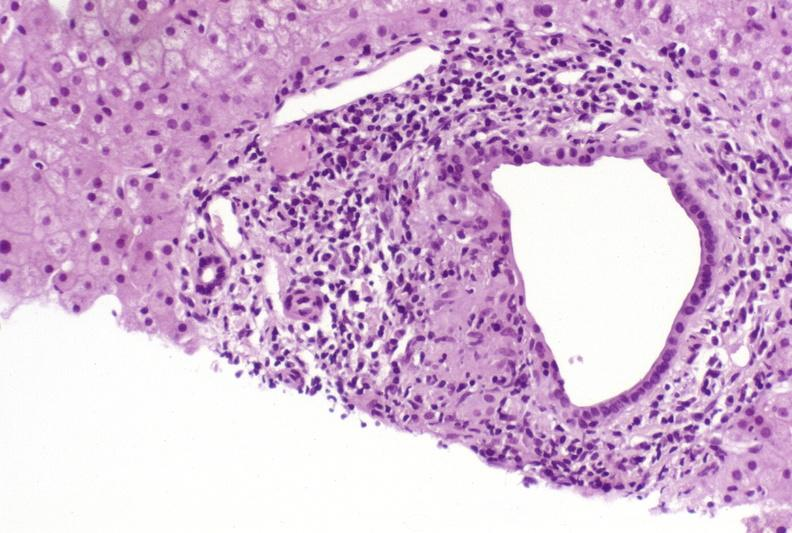s liver present?
Answer the question using a single word or phrase. Yes 